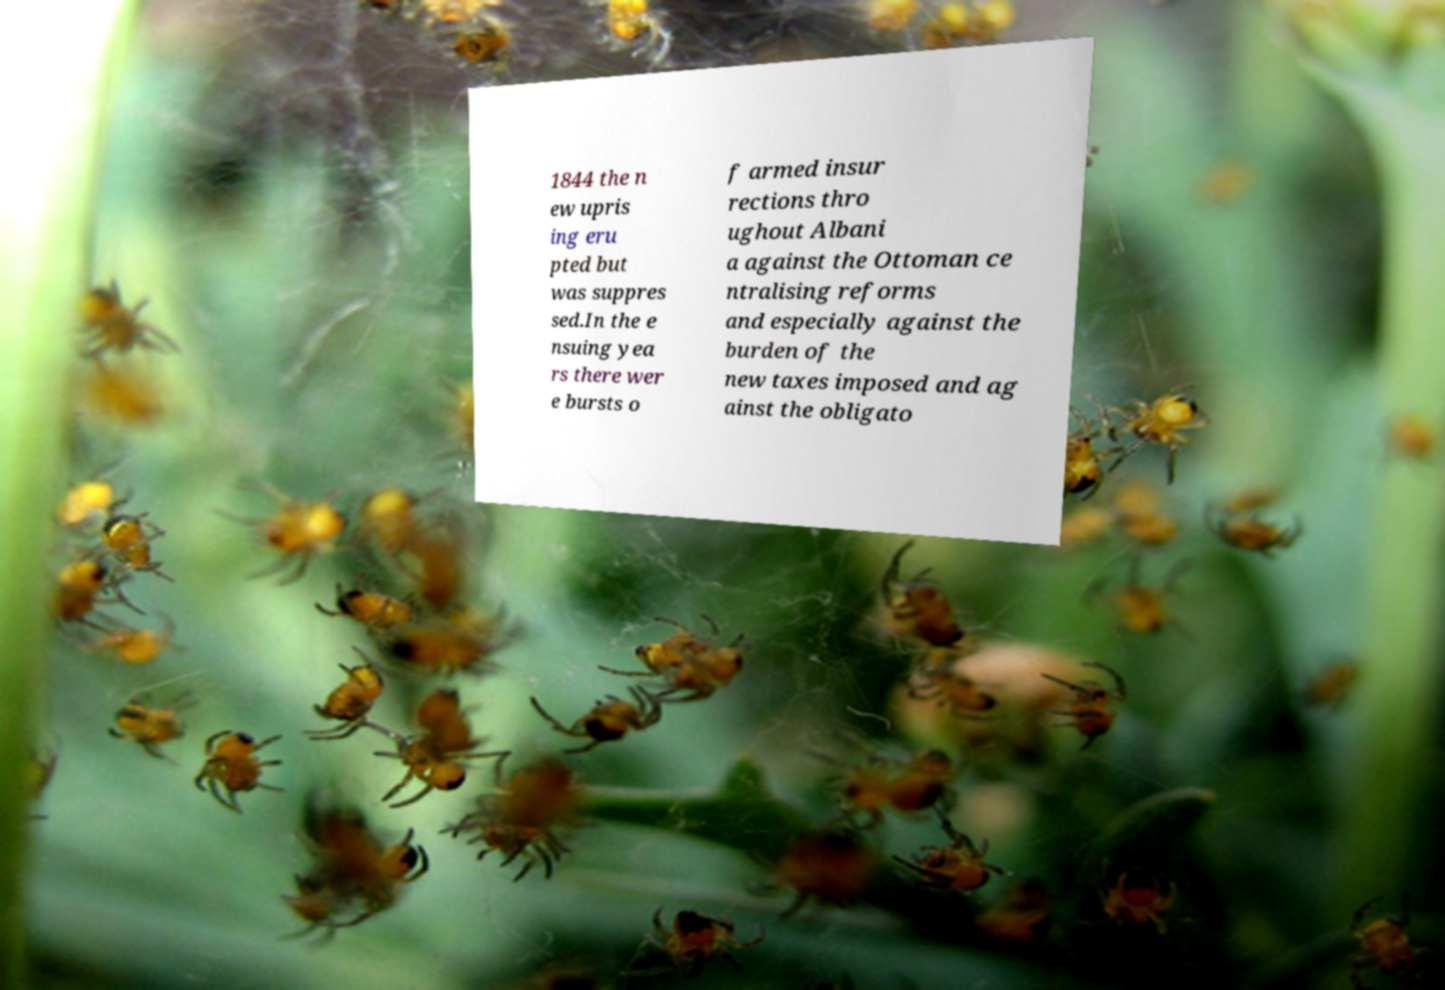Please read and relay the text visible in this image. What does it say? 1844 the n ew upris ing eru pted but was suppres sed.In the e nsuing yea rs there wer e bursts o f armed insur rections thro ughout Albani a against the Ottoman ce ntralising reforms and especially against the burden of the new taxes imposed and ag ainst the obligato 